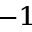Convert formula to latex. <formula><loc_0><loc_0><loc_500><loc_500>^ { - 1 }</formula> 